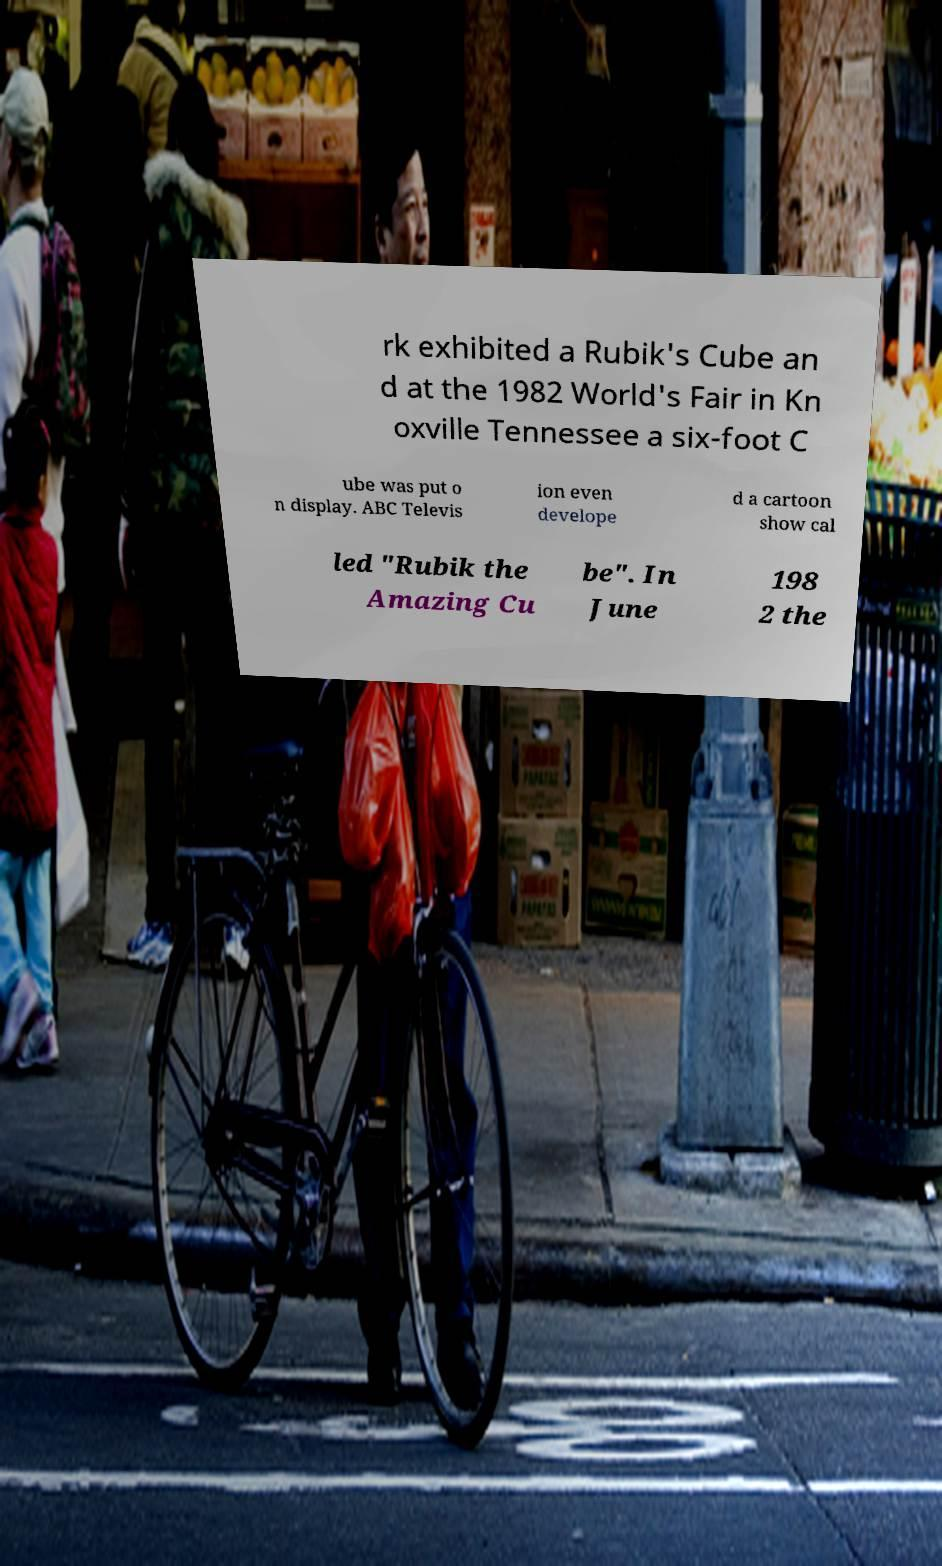Please read and relay the text visible in this image. What does it say? rk exhibited a Rubik's Cube an d at the 1982 World's Fair in Kn oxville Tennessee a six-foot C ube was put o n display. ABC Televis ion even develope d a cartoon show cal led "Rubik the Amazing Cu be". In June 198 2 the 